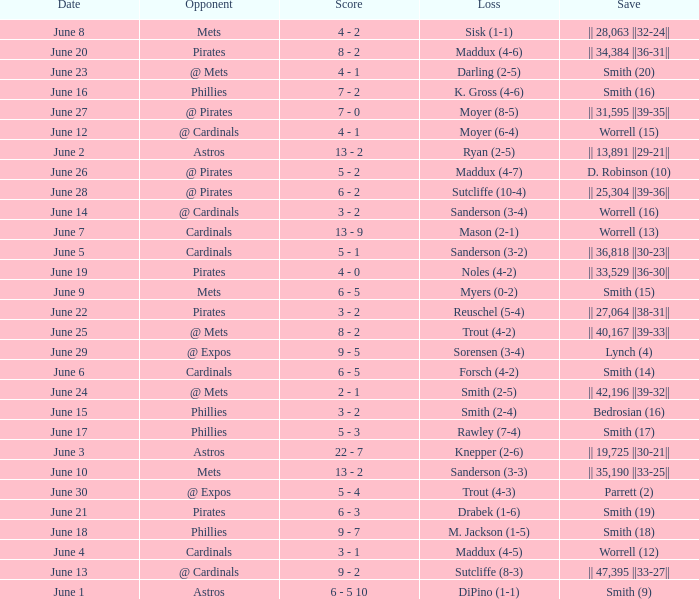On which day did the Chicago Cubs have a loss of trout (4-2)? June 25. 